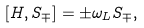<formula> <loc_0><loc_0><loc_500><loc_500>[ H , S _ { \mp } ] = \pm \omega _ { L } S _ { \mp } ,</formula> 